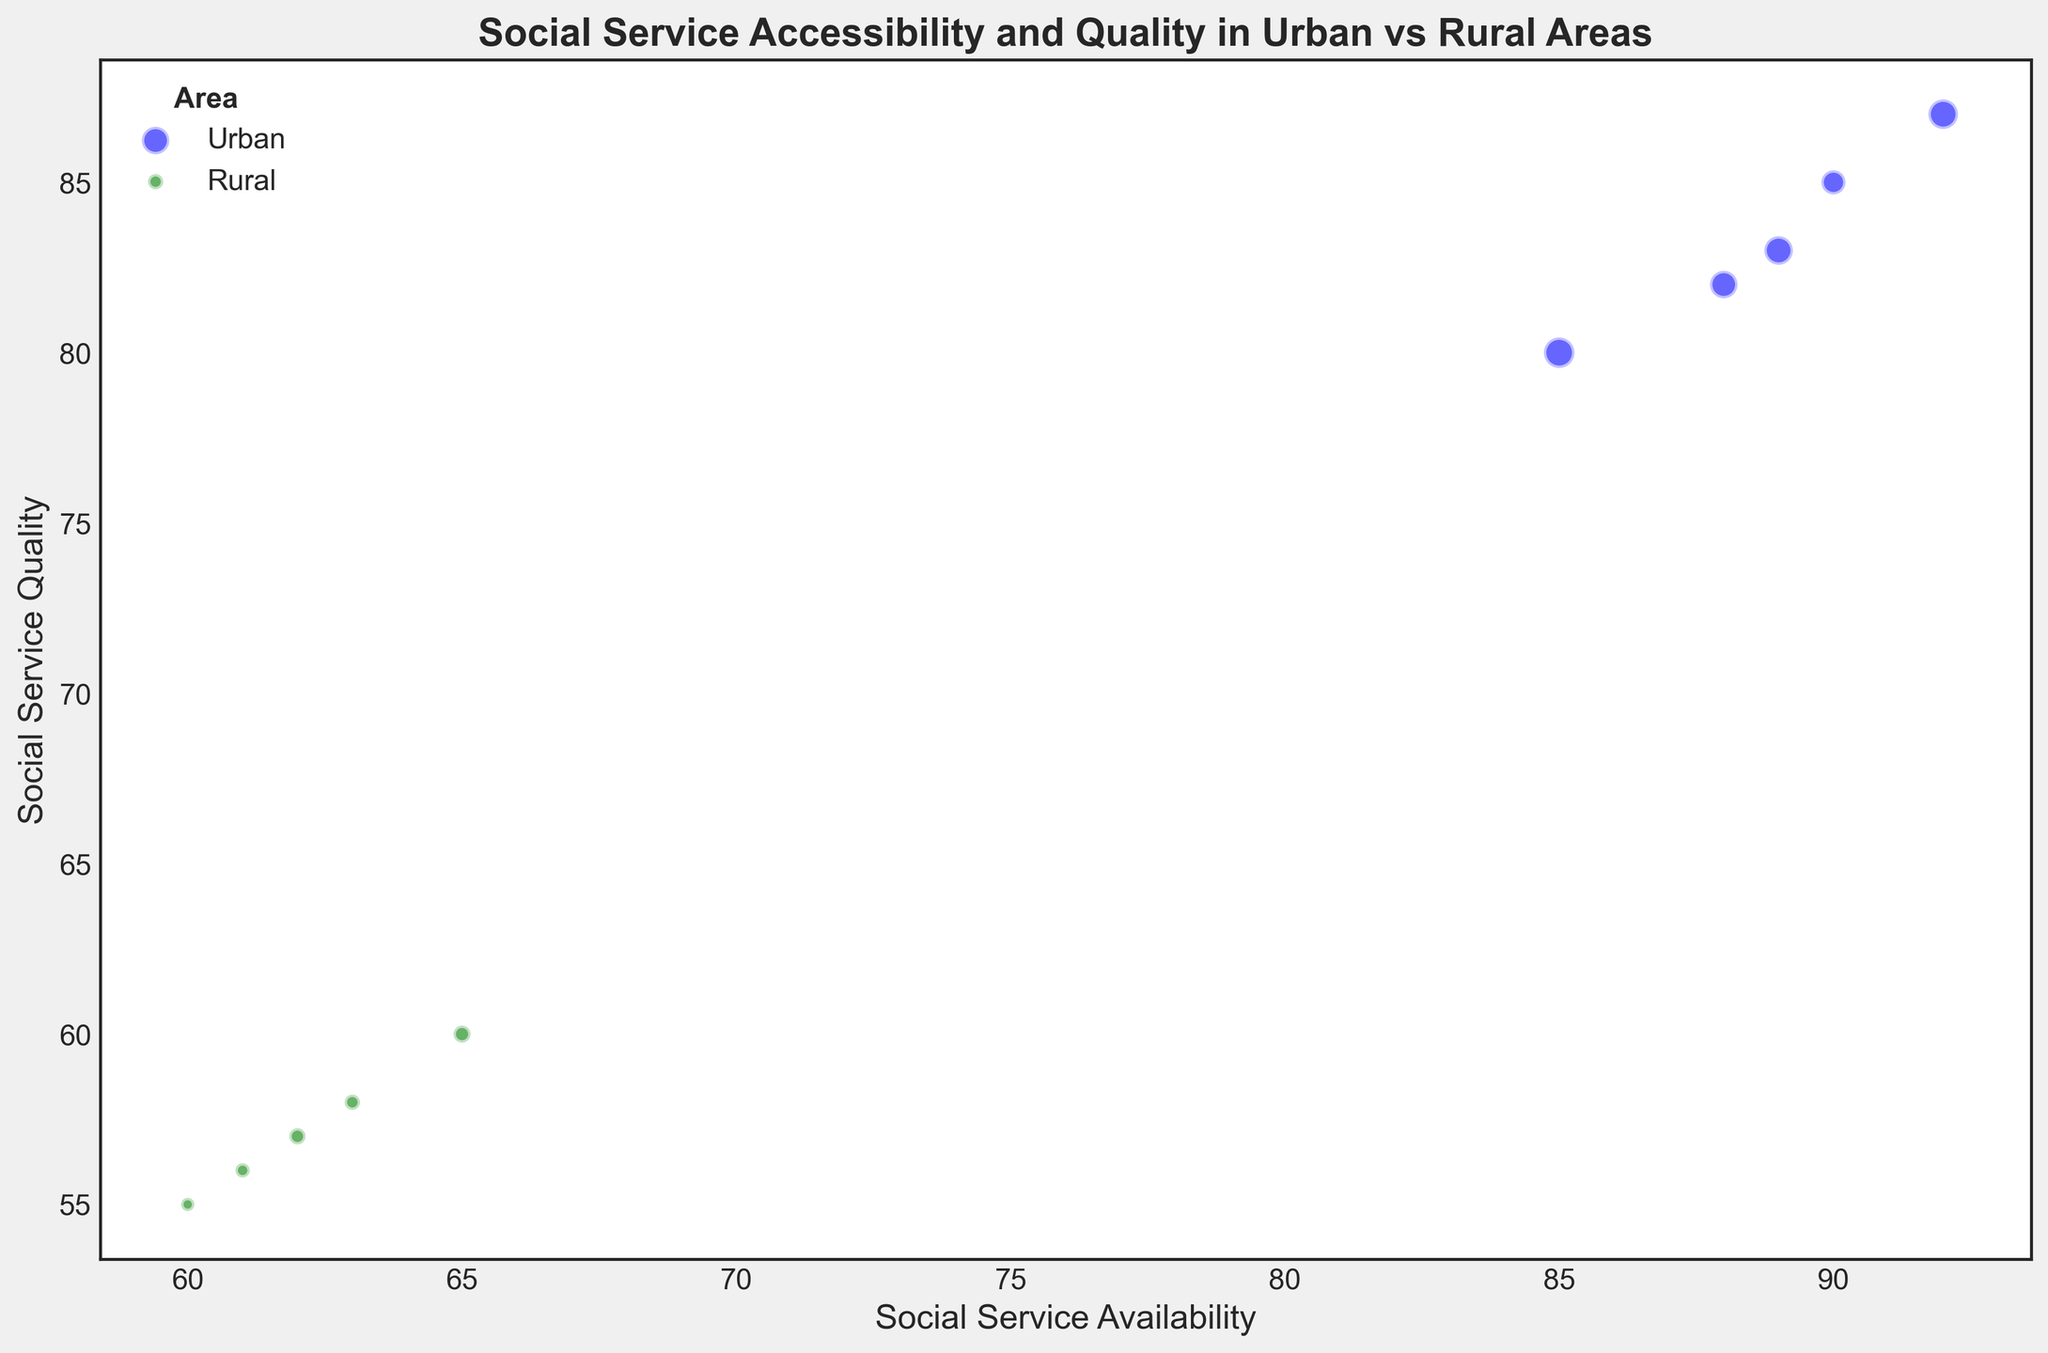Which area, Urban or Rural, has generally higher Social Service Availability? By looking at the position of the bubbles, Urban areas are more to the right, indicating higher Social Service Availability compared to Rural areas.
Answer: Urban Which has greater social service quality, Urban or Rural areas, on average? The Urban bubbles are generally placed higher on the axis of Social Service Quality compared to the Rural bubbles. Hence, Urban areas have greater average social service quality.
Answer: Urban Compare the range of Social Service Availability between Urban and Rural areas. The Social Service Availability for Urban areas ranges from 85 to 92, while for Rural areas it ranges from 60 to 65.
Answer: Urban: 85-92, Rural: 60-65 What is the approximate size of the largest bubble in the figure? The largest bubble is clearly a significant outlier in size. It results from the data with “Urban” and “PopulationDensity” 1200, giving it size 150.
Answer: 150 Is there an Urban bubble corresponding to a Social Service Availability of 1000 or less? All urban bubbles have Social Service Availability above 85, none of them are 1000 or less.
Answer: No What is the smallest size for a rural area bubble shown in the figure? By looking at the smallest bubbles in the Rural category, the size is determined by the data point providing the size of 30.
Answer: 30 In which area, Urban or Rural, is the relationship between Social Service Availability and Social Service Quality stronger? Urban bubbles are more tightly clustered, indicating a stronger relationship between social service availability and quality compared to the more dispersed Rural bubbles.
Answer: Urban What can you say about Social Service Availability in high Population Density Urban areas? As Population Density increases in Urban areas, Social Service Availability tends to increase but fluctuates around higher values without a strict trend.
Answer: Increases and fluctuates Considering the average size of bubbles, which has larger populations, Urban or Rural areas? The sizes of Urban bubbles are generally larger, indicating higher populations compared to smaller Rural bubbles.
Answer: Urban If you were to guess the highest social service quality among rural areas, what would it be? The highest bubble in the rural category, representing the highest Social Service Quality, is around 60.
Answer: 60 